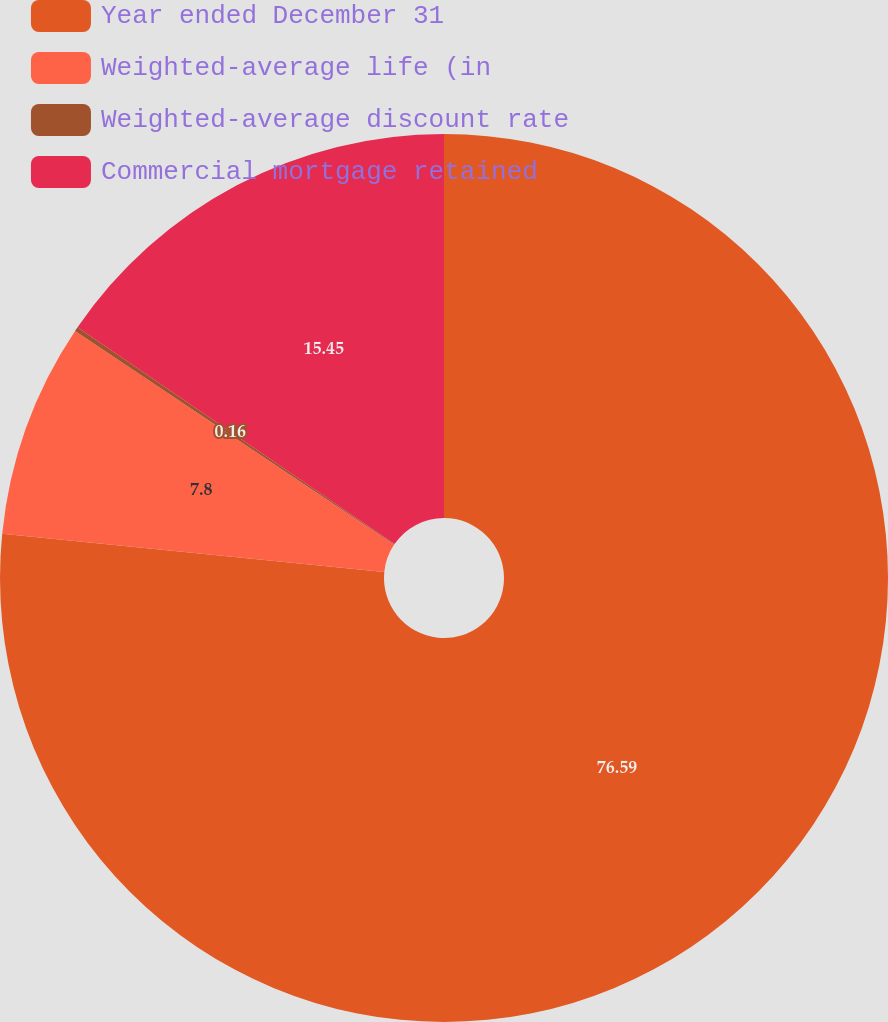Convert chart. <chart><loc_0><loc_0><loc_500><loc_500><pie_chart><fcel>Year ended December 31<fcel>Weighted-average life (in<fcel>Weighted-average discount rate<fcel>Commercial mortgage retained<nl><fcel>76.59%<fcel>7.8%<fcel>0.16%<fcel>15.45%<nl></chart> 